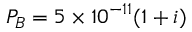<formula> <loc_0><loc_0><loc_500><loc_500>P _ { B } = 5 \times 1 0 ^ { - 1 1 } ( 1 + i )</formula> 